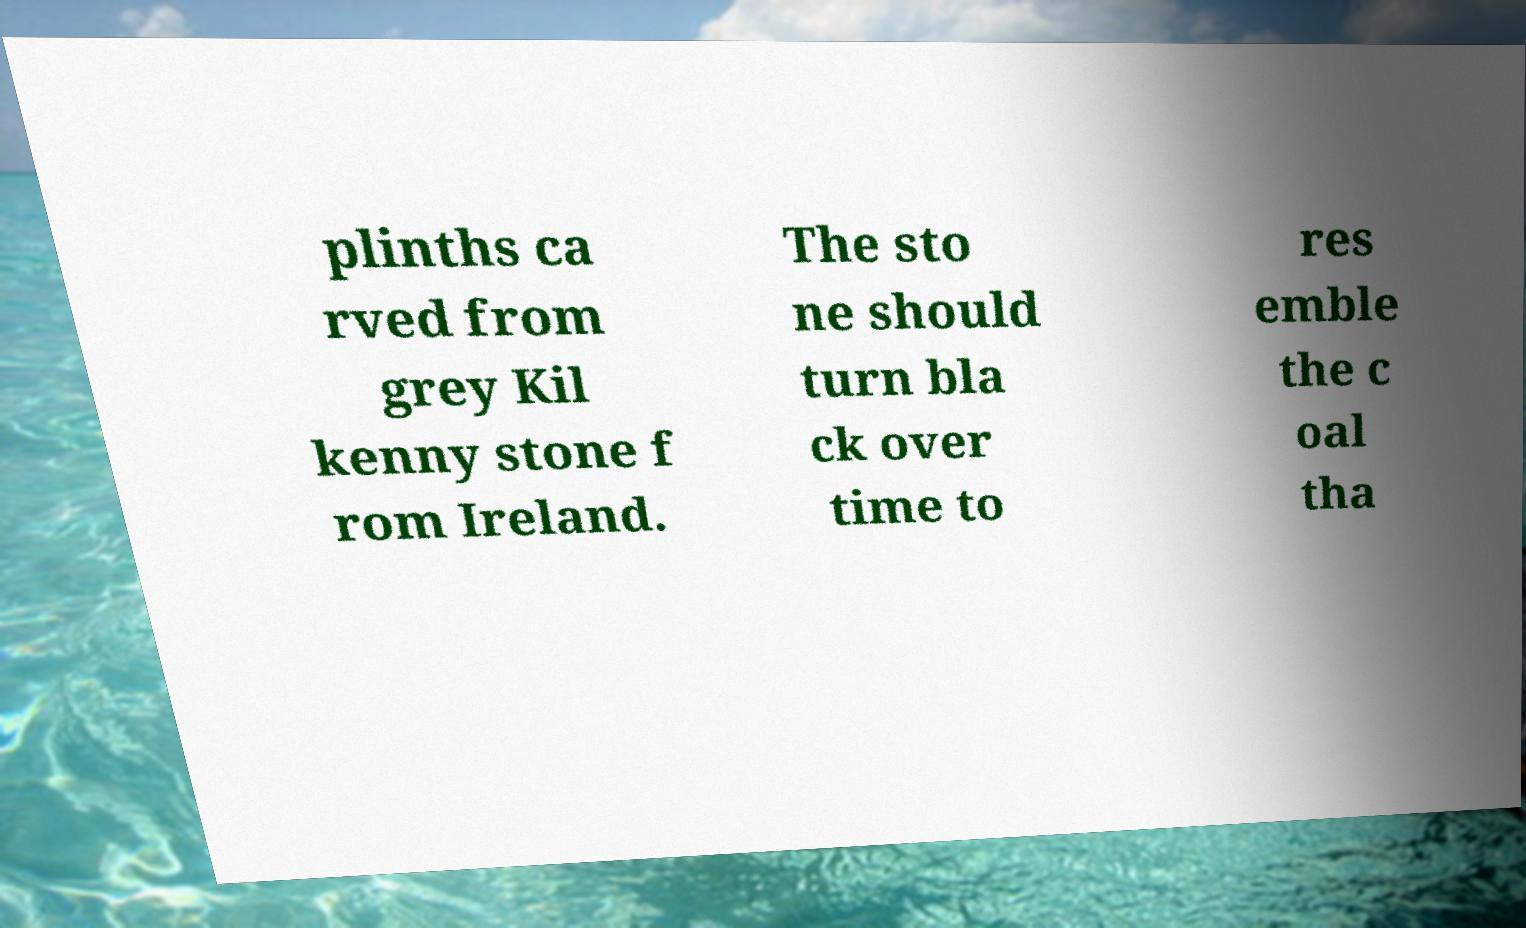Please identify and transcribe the text found in this image. plinths ca rved from grey Kil kenny stone f rom Ireland. The sto ne should turn bla ck over time to res emble the c oal tha 